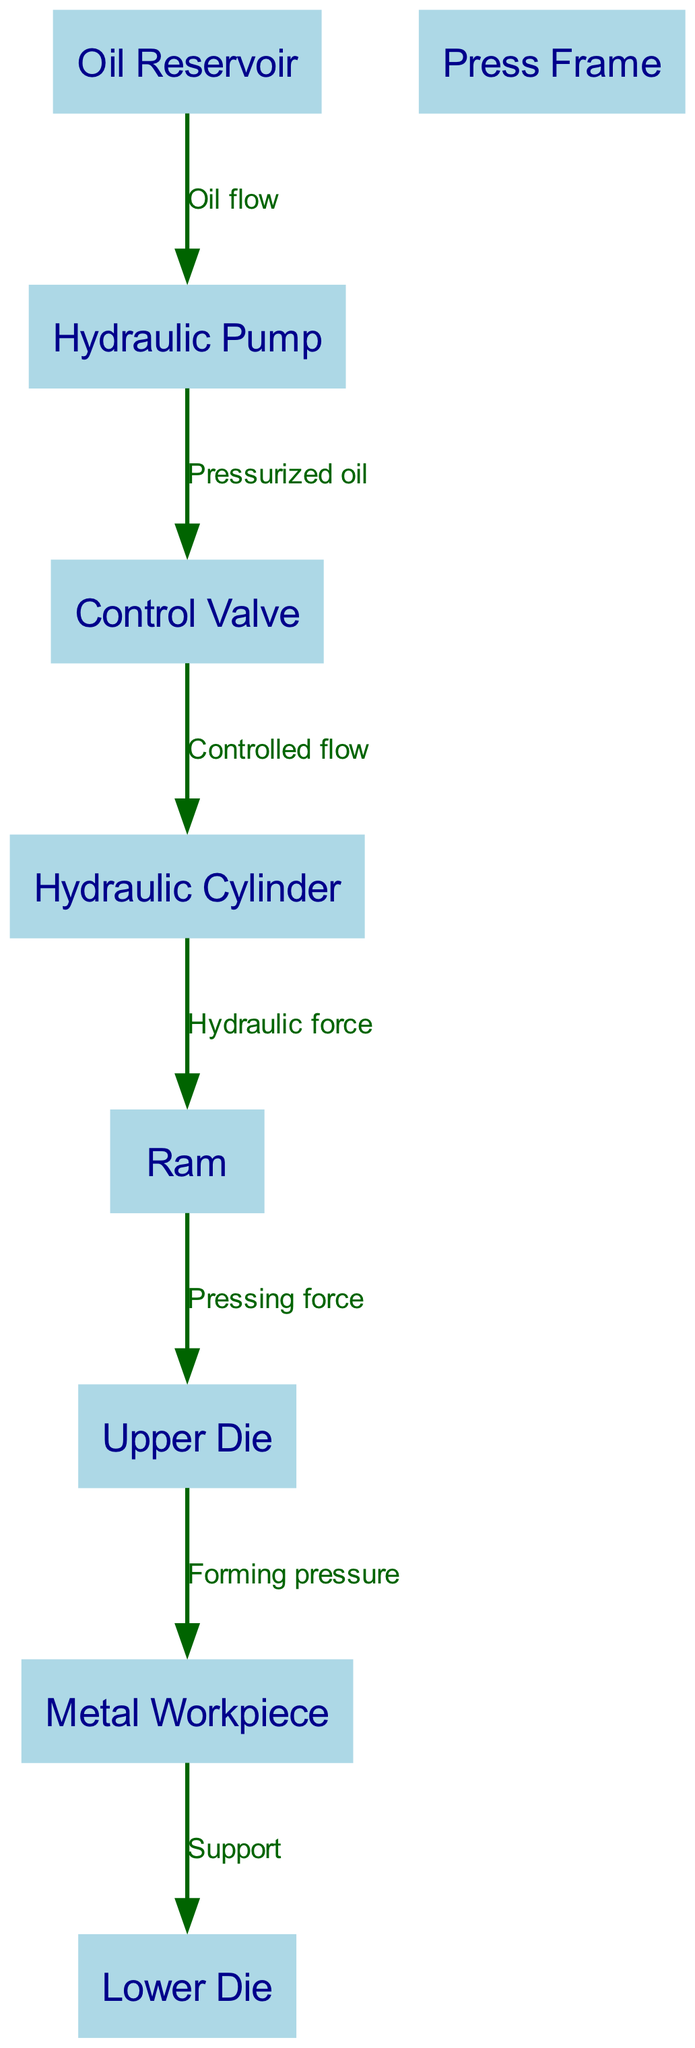What component controls the flow of pressurized oil? From the diagram, the node labeled "Control Valve" is indicated to control the flow of pressurized oil coming from the "Hydraulic Pump" before directing it to the "Hydraulic Cylinder."
Answer: Control Valve How many nodes are present in this hydraulic press diagram? By counting the listed nodes in the diagram, I see there are eight distinct nodes: Hydraulic Cylinder, Ram, Upper Die, Lower Die, Metal Workpiece, Oil Reservoir, Hydraulic Pump, and Control Valve.
Answer: 8 What is the direct output force of the ram? Tracing the flow from the "Ram" node, it directly applies a "Pressing force" to the "Upper Die." The arrow indicates a direct output from the ram to the upper die.
Answer: Pressing force What is the role of the oil reservoir in the system? The "Oil Reservoir" serves as the source of oil that flows to the "Hydraulic Pump," and it is indicated in the diagram that it is the starting point for oil flow to initiate hydraulic action.
Answer: Source of oil Which component provides support to the workpiece? In the diagram, it shows that the "Lower Die" is positioned beneath the "Metal Workpiece" and provides support, as indicated by the arrow pointing from the workpiece to the lower die.
Answer: Lower Die What flows from the pump to the control valve? Analyzing the connections in the diagram, it confirms that "Pressurized oil" flows from the "Hydraulic Pump" to the "Control Valve," which regulates that flow.
Answer: Pressurized oil What is the first step in the oil flow process? The first step starts with the "Oil Reservoir," which feeds oil to the "Hydraulic Pump," initiating the oil flow process as shown in the diagram.
Answer: Oil Reservoir What action does the hydraulic cylinder perform? The diagram indicates that the "Hydraulic Cylinder" translates the "Controlled flow" received from the "Control Valve" into "Hydraulic force," which is an essential action in the process.
Answer: Hydraulic force 